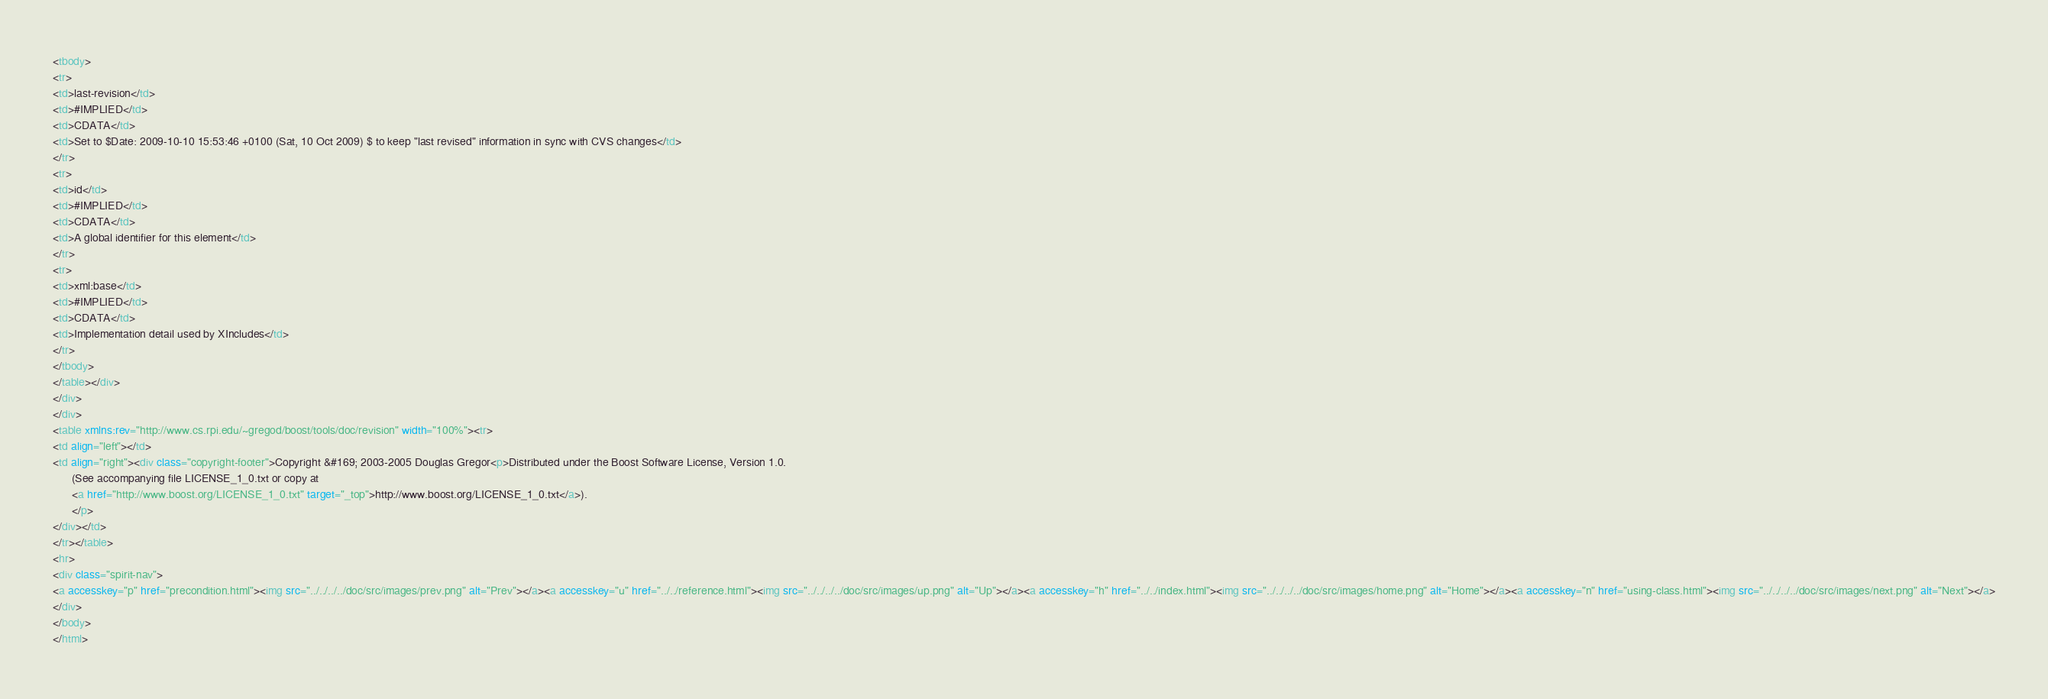<code> <loc_0><loc_0><loc_500><loc_500><_HTML_><tbody>
<tr>
<td>last-revision</td>
<td>#IMPLIED</td>
<td>CDATA</td>
<td>Set to $Date: 2009-10-10 15:53:46 +0100 (Sat, 10 Oct 2009) $ to keep "last revised" information in sync with CVS changes</td>
</tr>
<tr>
<td>id</td>
<td>#IMPLIED</td>
<td>CDATA</td>
<td>A global identifier for this element</td>
</tr>
<tr>
<td>xml:base</td>
<td>#IMPLIED</td>
<td>CDATA</td>
<td>Implementation detail used by XIncludes</td>
</tr>
</tbody>
</table></div>
</div>
</div>
<table xmlns:rev="http://www.cs.rpi.edu/~gregod/boost/tools/doc/revision" width="100%"><tr>
<td align="left"></td>
<td align="right"><div class="copyright-footer">Copyright &#169; 2003-2005 Douglas Gregor<p>Distributed under the Boost Software License, Version 1.0.
      (See accompanying file LICENSE_1_0.txt or copy at
      <a href="http://www.boost.org/LICENSE_1_0.txt" target="_top">http://www.boost.org/LICENSE_1_0.txt</a>).
      </p>
</div></td>
</tr></table>
<hr>
<div class="spirit-nav">
<a accesskey="p" href="precondition.html"><img src="../../../../doc/src/images/prev.png" alt="Prev"></a><a accesskey="u" href="../../reference.html"><img src="../../../../doc/src/images/up.png" alt="Up"></a><a accesskey="h" href="../../index.html"><img src="../../../../doc/src/images/home.png" alt="Home"></a><a accesskey="n" href="using-class.html"><img src="../../../../doc/src/images/next.png" alt="Next"></a>
</div>
</body>
</html>
</code> 